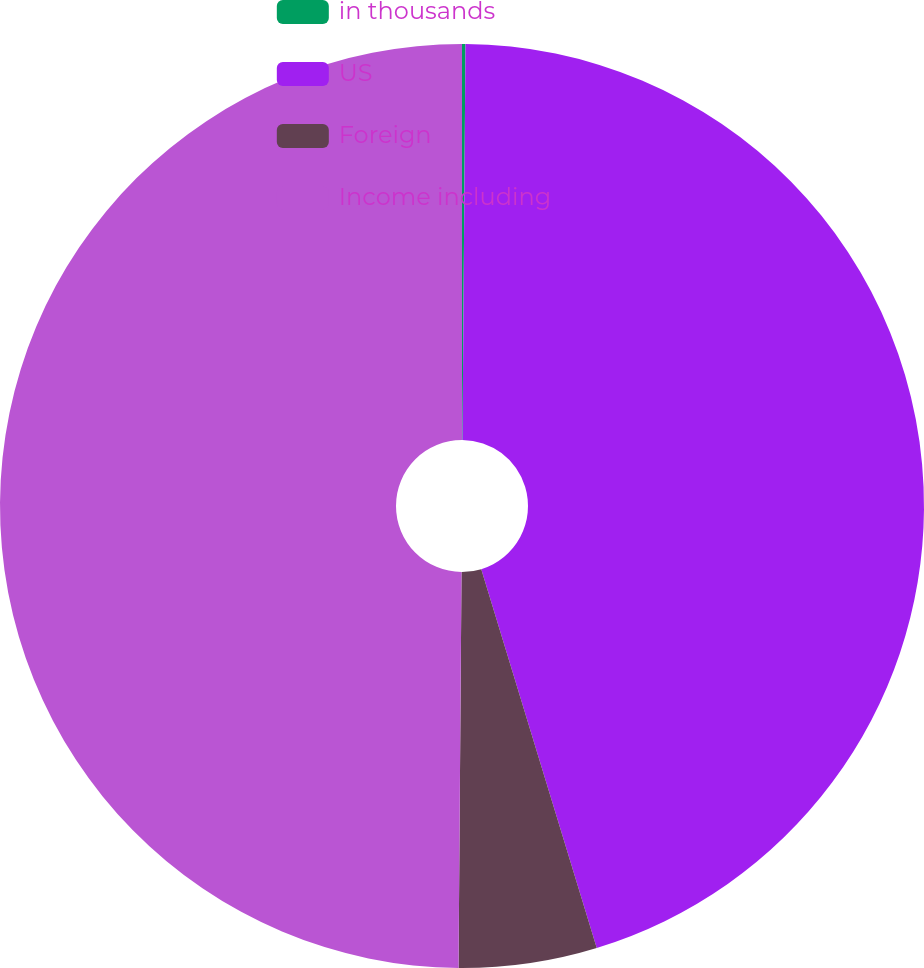<chart> <loc_0><loc_0><loc_500><loc_500><pie_chart><fcel>in thousands<fcel>US<fcel>Foreign<fcel>Income including<nl><fcel>0.12%<fcel>45.17%<fcel>4.83%<fcel>49.88%<nl></chart> 